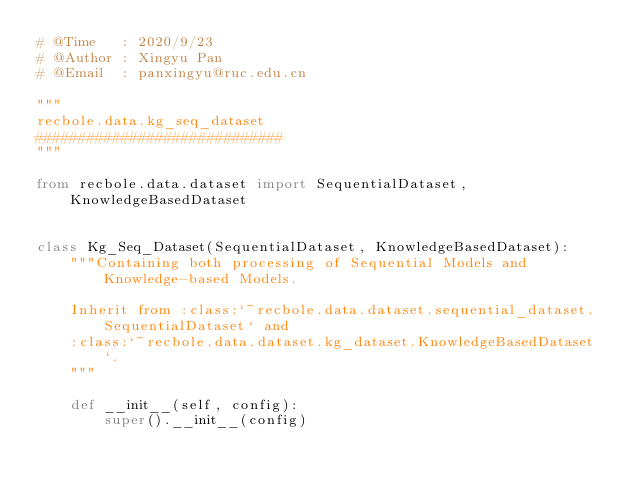Convert code to text. <code><loc_0><loc_0><loc_500><loc_500><_Python_># @Time   : 2020/9/23
# @Author : Xingyu Pan
# @Email  : panxingyu@ruc.edu.cn

"""
recbole.data.kg_seq_dataset
#############################
"""

from recbole.data.dataset import SequentialDataset, KnowledgeBasedDataset


class Kg_Seq_Dataset(SequentialDataset, KnowledgeBasedDataset):
    """Containing both processing of Sequential Models and Knowledge-based Models.

    Inherit from :class:`~recbole.data.dataset.sequential_dataset.SequentialDataset` and
    :class:`~recbole.data.dataset.kg_dataset.KnowledgeBasedDataset`.
    """

    def __init__(self, config):
        super().__init__(config)
</code> 